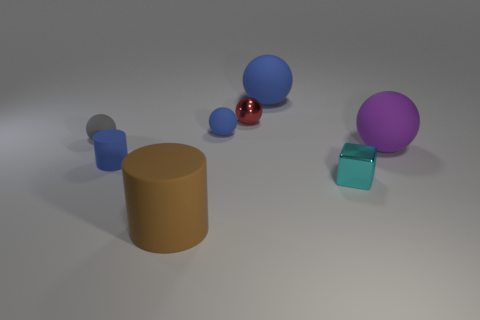Is the shape of the small gray matte object the same as the big purple rubber object?
Offer a very short reply. Yes. How many small blue things are on the left side of the tiny blue ball?
Offer a very short reply. 1. What number of things are large brown metallic cubes or large blue matte spheres?
Offer a terse response. 1. How many gray spheres are the same size as the purple ball?
Offer a very short reply. 0. The metallic object that is in front of the ball that is to the right of the large blue ball is what shape?
Ensure brevity in your answer.  Cube. Are there fewer matte balls than large blue rubber objects?
Make the answer very short. No. What color is the large rubber object behind the small red sphere?
Provide a short and direct response. Blue. The thing that is both in front of the tiny blue cylinder and on the right side of the brown matte cylinder is made of what material?
Make the answer very short. Metal. What shape is the gray object that is the same material as the blue cylinder?
Your answer should be very brief. Sphere. What number of shiny things are on the left side of the small object that is to the right of the tiny red thing?
Make the answer very short. 1. 